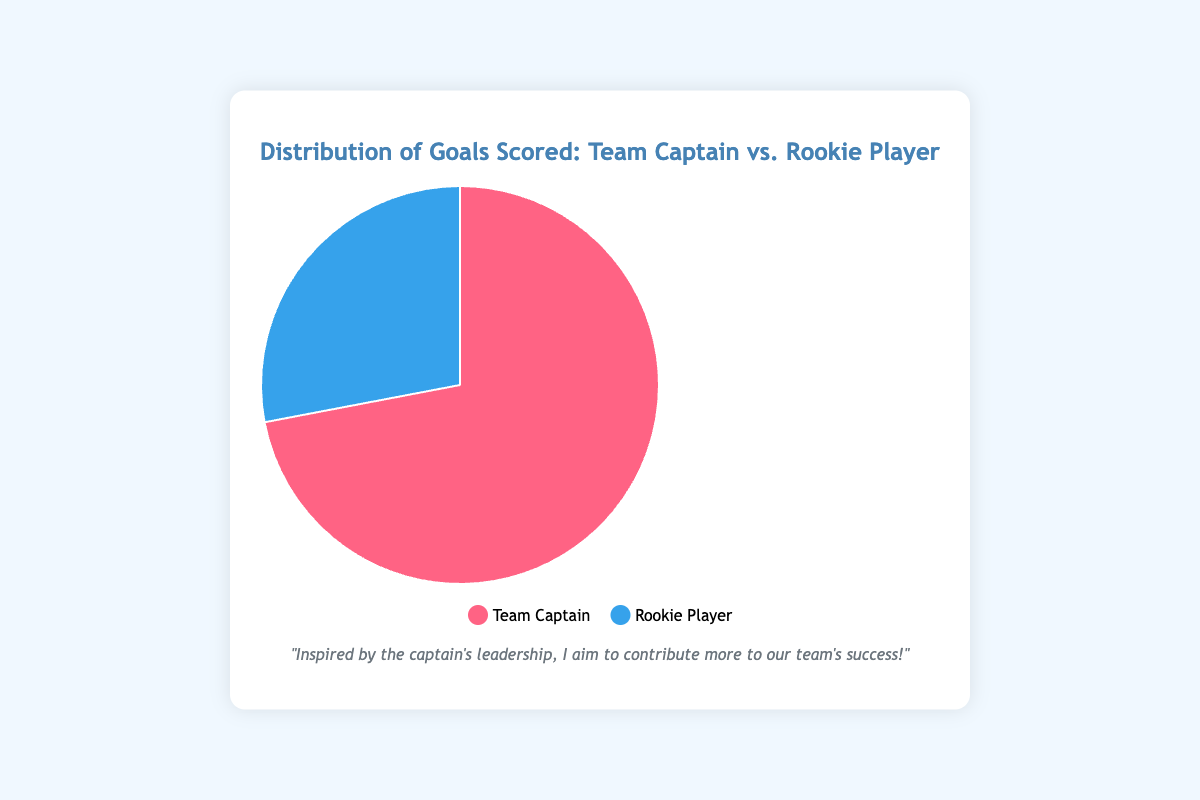What is the total number of goals scored by both players? The figure shows the goals scored by Team Captain John Smith (18 goals) and Rookie Player Alex Johnson (7 goals). To find the total, we sum the goals scored by both players: 18 + 7 = 25 goals.
Answer: 25 goals How many more goals did the team captain score compared to the rookie player? The figure shows that Team Captain John Smith scored 18 goals, and Rookie Player Alex Johnson scored 7 goals. To find out how many more goals the captain scored, we subtract the rookie's goals from the captain's goals: 18 - 7 = 11 goals.
Answer: 11 goals What percentage of the total goals did the rookie player score? The total number of goals scored by both players is 25. The rookie player scored 7 goals. To find the percentage, we calculate (7 / 25) * 100.
Answer: 28% Which player scored the majority of the goals? By visual inspection from the pie chart, the larger section represents the Team Captain. This tells us John Smith scored more goals compared to the Rookie Player Alex Johnson.
Answer: John Smith What is the ratio of goals scored by Team Captain to Rookie Player? The figure shows Team Captain John Smith scored 18 goals and Rookie Player Alex Johnson scored 7 goals. The ratio of goals scored by the Team Captain to the Rookie Player is 18:7.
Answer: 18:7 If the rookie player scores 4 more goals this season, what will be his new share of the total goals? Assume the team captain's goals remain the same. Currently, the rookie player has scored 7 goals and the team captain scored 18, making the total 25 goals. If the rookie scores 4 more goals, his total will be 7 + 4 = 11 goals. The new total of goals scored by both players will be 18 + 11 = 29 goals. The rookie's share of the total will then be (11 / 29) * 100.
Answer: 37.93% What is the color associated with the team captain in the chart? The legend indicates that the color associated with the team captain is red.
Answer: Red What visual element indicates the player who has scored more goals in the chart? The pie chart visually represents the distribution, with larger slices indicating more goals scored. The team captain has the larger slice.
Answer: Larger slice If both players scored 3 more goals each, would the rookie player's share of the total goals increase, decrease, or stay the same? Both scoring 3 more goals means the team captain will have 21 goals and the rookie will have 10 goals. The new total number of goals will be 21 + 10 = 31. The rookie's new share is (10 / 31) * 100, and calculating this percentage can show whether it increased or decreased from the current percentage. The current percentage is 28%.
Answer: Decrease 